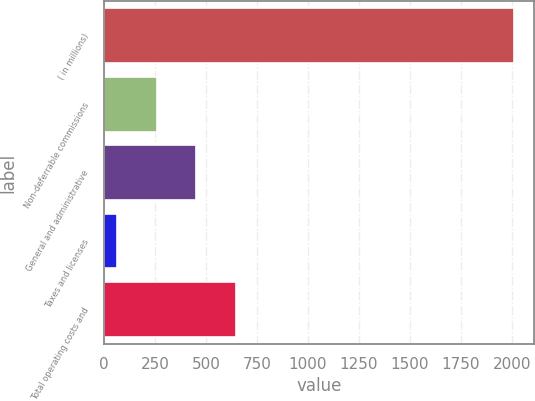Convert chart to OTSL. <chart><loc_0><loc_0><loc_500><loc_500><bar_chart><fcel>( in millions)<fcel>Non-deferrable commissions<fcel>General and administrative<fcel>Taxes and licenses<fcel>Total operating costs and<nl><fcel>2010<fcel>257.7<fcel>452.4<fcel>63<fcel>647.1<nl></chart> 